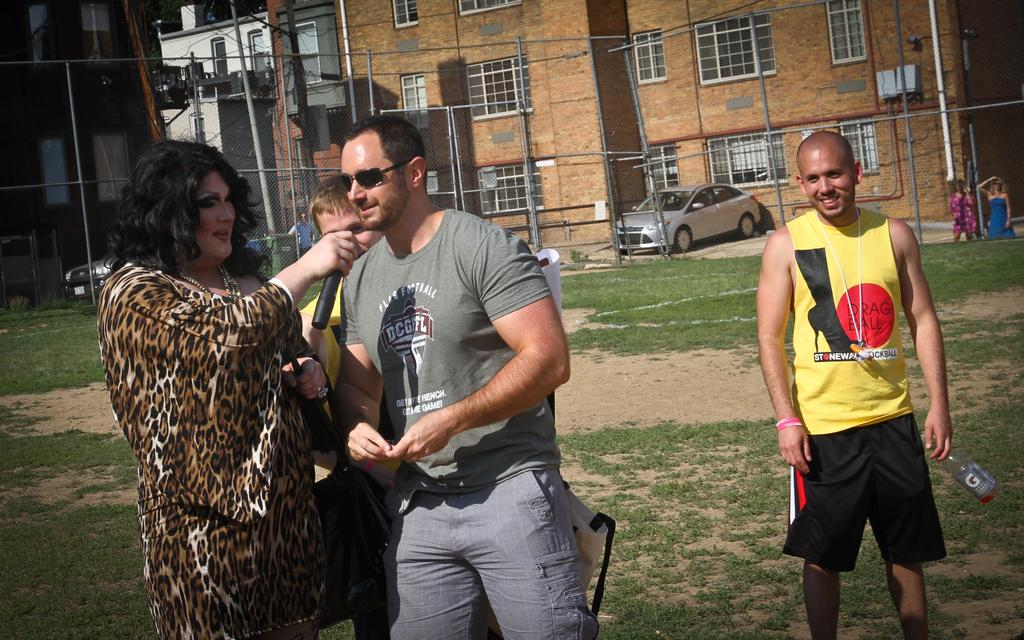What is the main subject of the image? The main subject of the image is a group of people standing. Can you describe the person holding an object in the image? Yes, there is a person holding a microphone in the image. What can be seen in the background of the image? In the background of the image, there are poles, buildings, and vehicles on the road. What type of bells can be heard ringing in the image? There are no bells present in the image, and therefore no sound can be heard. Can you describe the straw that is being used by the person holding the microphone? There is no straw present in the image; the person is holding a microphone. 